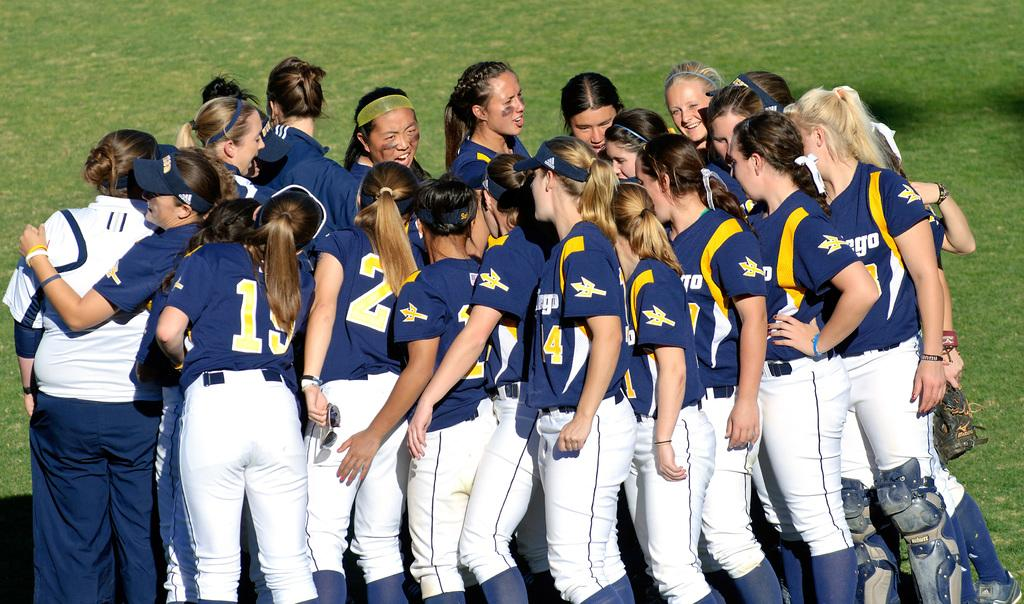Provide a one-sentence caption for the provided image. group of women ball players, numbers 19 & 4 are numbers showing. 